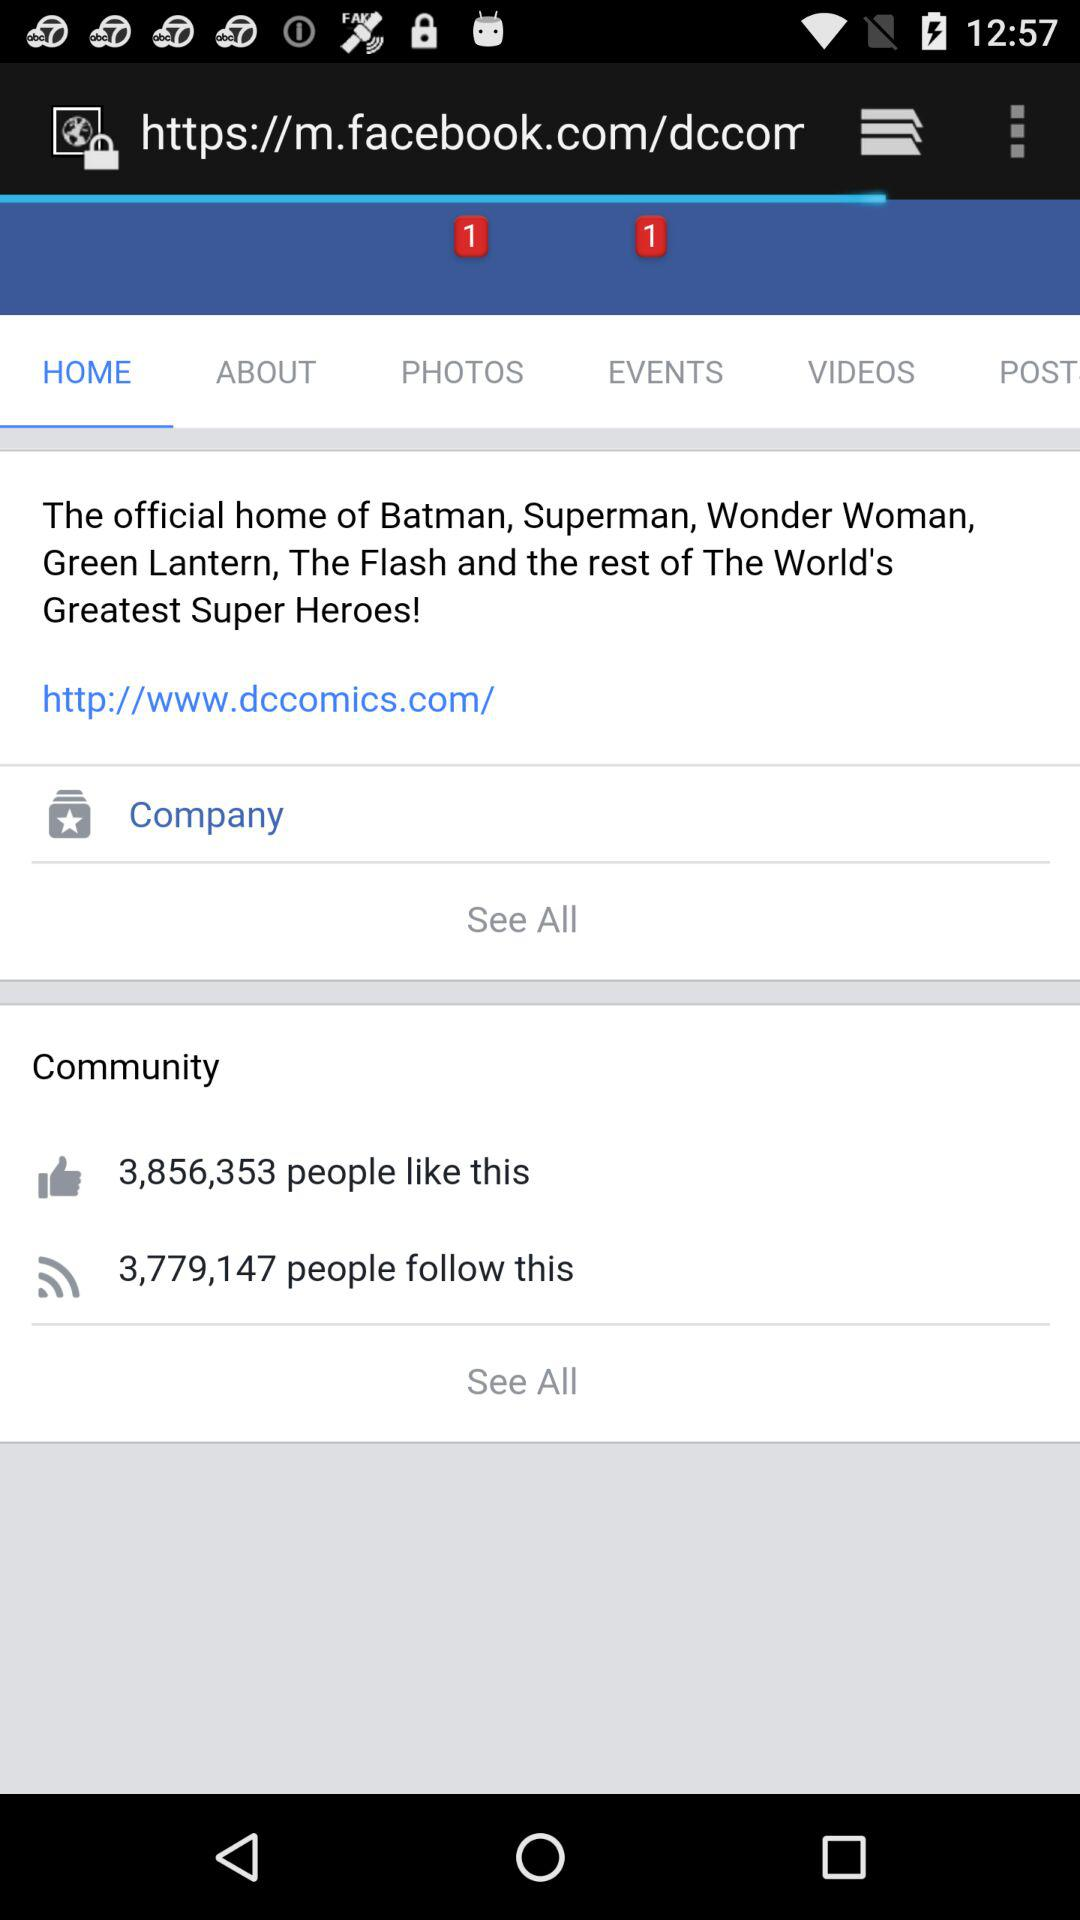Which bar has selected? The selected bar is "HOME". 